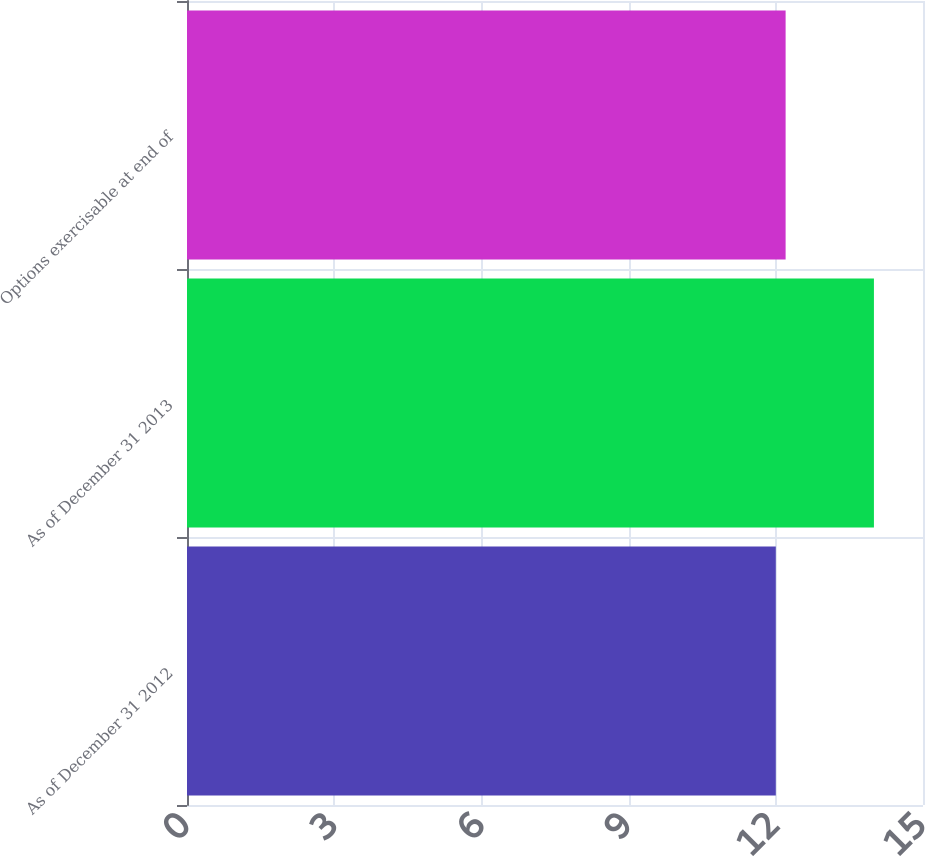Convert chart to OTSL. <chart><loc_0><loc_0><loc_500><loc_500><bar_chart><fcel>As of December 31 2012<fcel>As of December 31 2013<fcel>Options exercisable at end of<nl><fcel>12<fcel>14<fcel>12.2<nl></chart> 